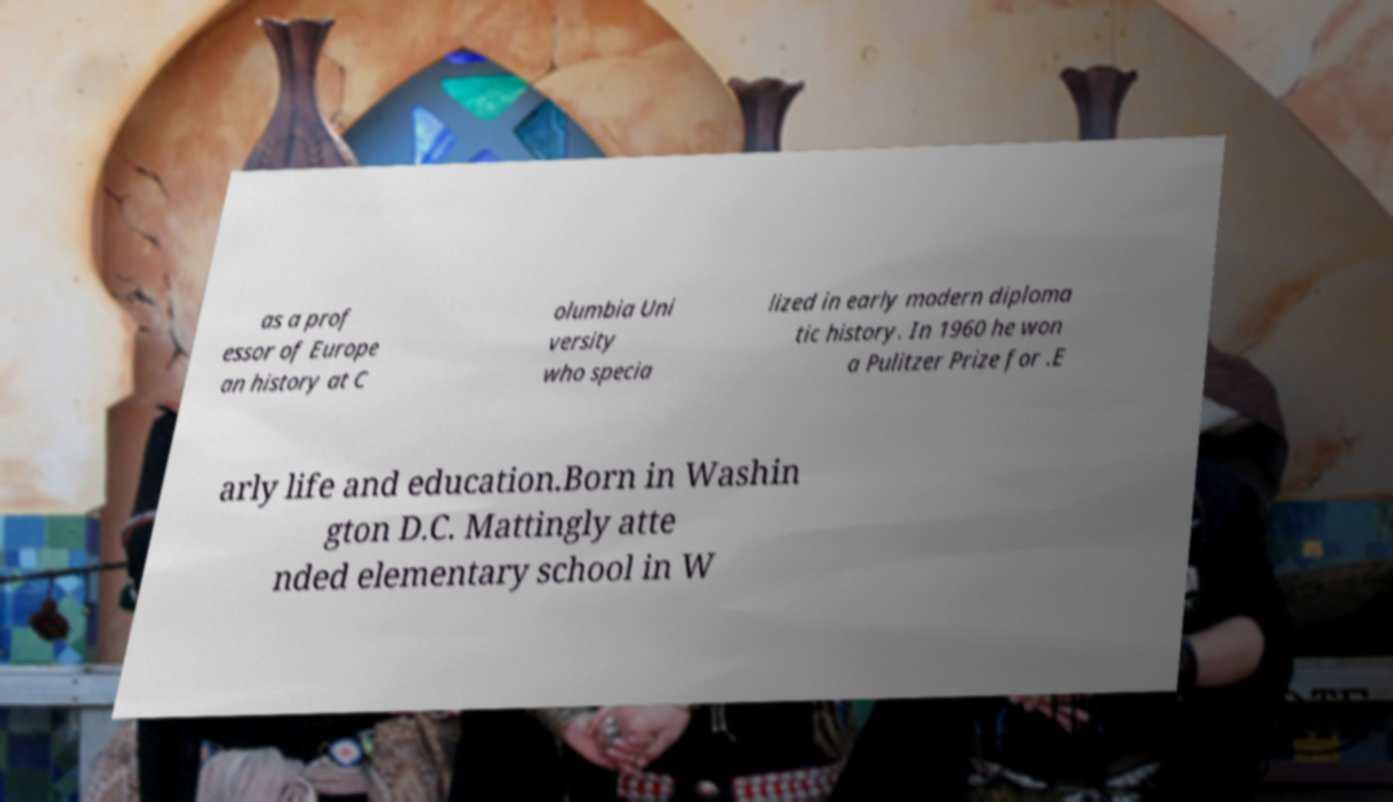What messages or text are displayed in this image? I need them in a readable, typed format. as a prof essor of Europe an history at C olumbia Uni versity who specia lized in early modern diploma tic history. In 1960 he won a Pulitzer Prize for .E arly life and education.Born in Washin gton D.C. Mattingly atte nded elementary school in W 